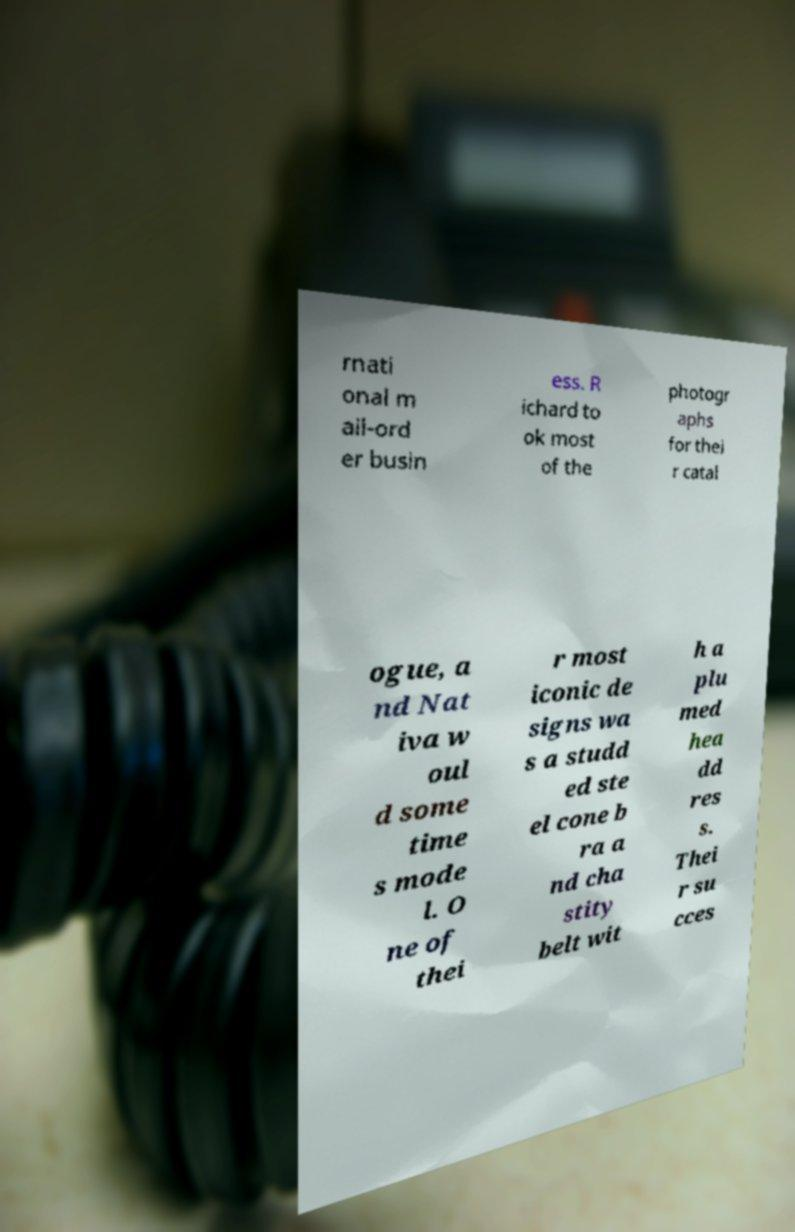For documentation purposes, I need the text within this image transcribed. Could you provide that? rnati onal m ail-ord er busin ess. R ichard to ok most of the photogr aphs for thei r catal ogue, a nd Nat iva w oul d some time s mode l. O ne of thei r most iconic de signs wa s a studd ed ste el cone b ra a nd cha stity belt wit h a plu med hea dd res s. Thei r su cces 